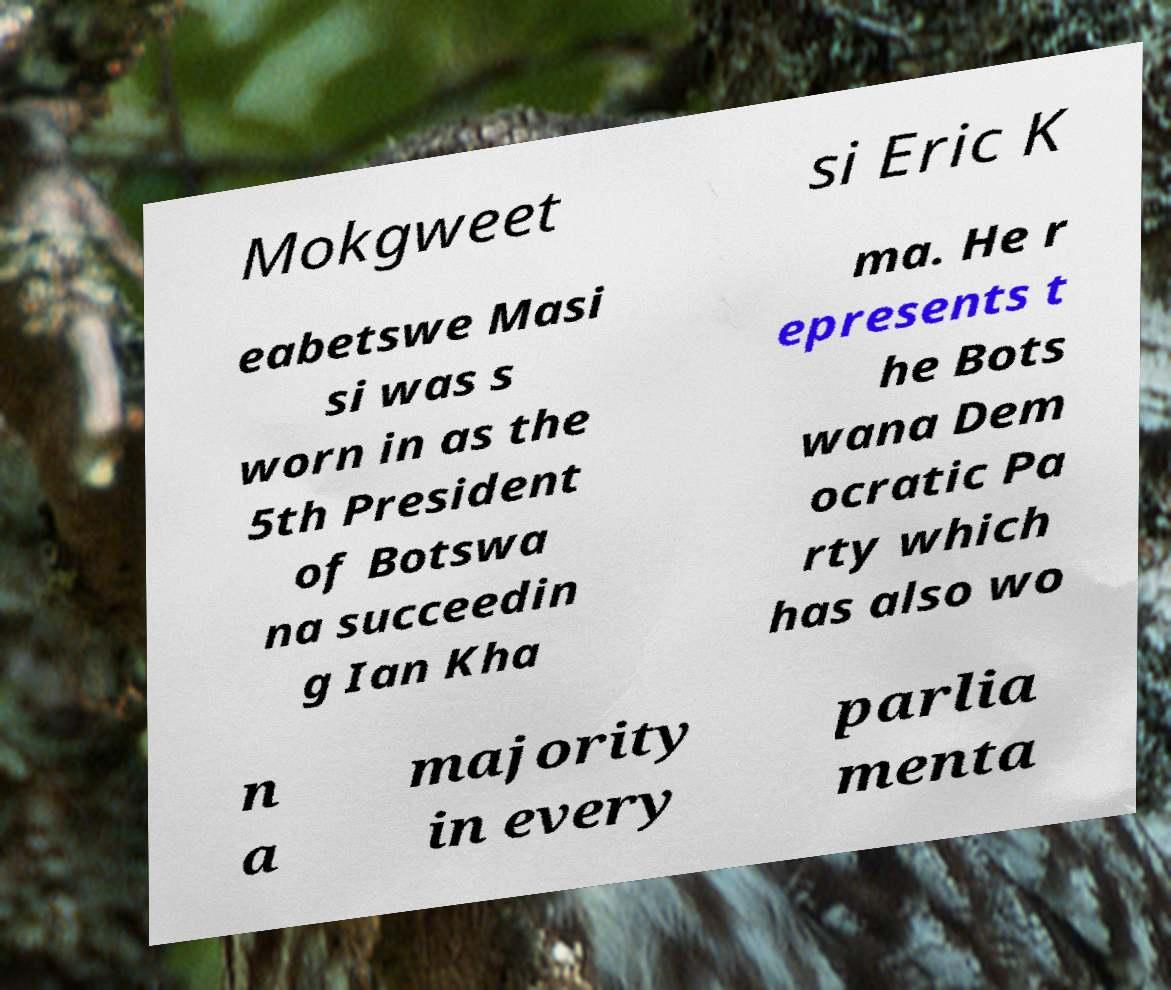Could you assist in decoding the text presented in this image and type it out clearly? Mokgweet si Eric K eabetswe Masi si was s worn in as the 5th President of Botswa na succeedin g Ian Kha ma. He r epresents t he Bots wana Dem ocratic Pa rty which has also wo n a majority in every parlia menta 